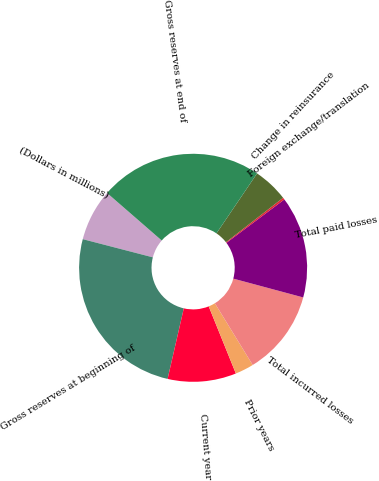Convert chart. <chart><loc_0><loc_0><loc_500><loc_500><pie_chart><fcel>(Dollars in millions)<fcel>Gross reserves at beginning of<fcel>Current year<fcel>Prior years<fcel>Total incurred losses<fcel>Total paid losses<fcel>Foreign exchange/translation<fcel>Change in reinsurance<fcel>Gross reserves at end of<nl><fcel>7.35%<fcel>25.45%<fcel>9.71%<fcel>2.64%<fcel>12.06%<fcel>14.42%<fcel>0.29%<fcel>5.0%<fcel>23.09%<nl></chart> 